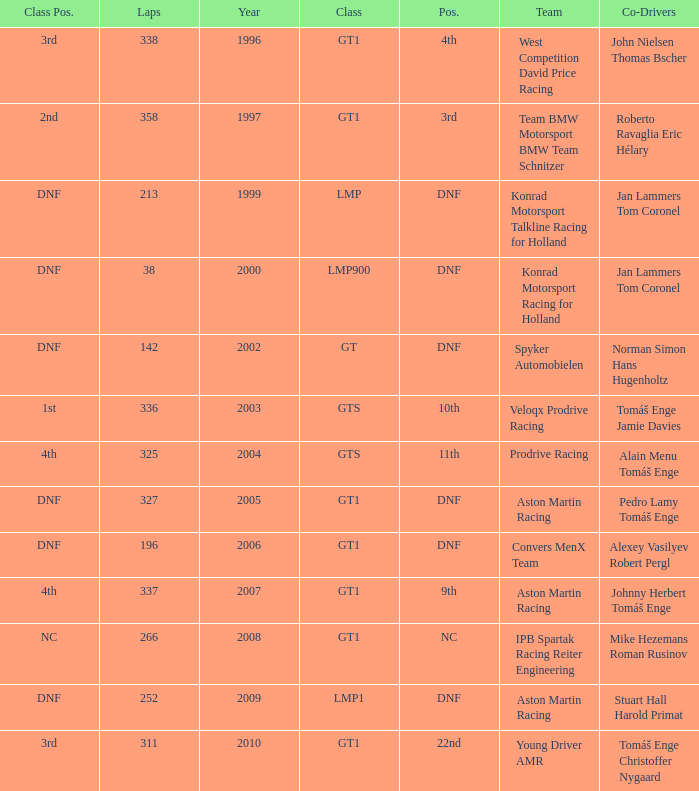Which team finished 3rd in class with 337 laps before 2008? West Competition David Price Racing. 